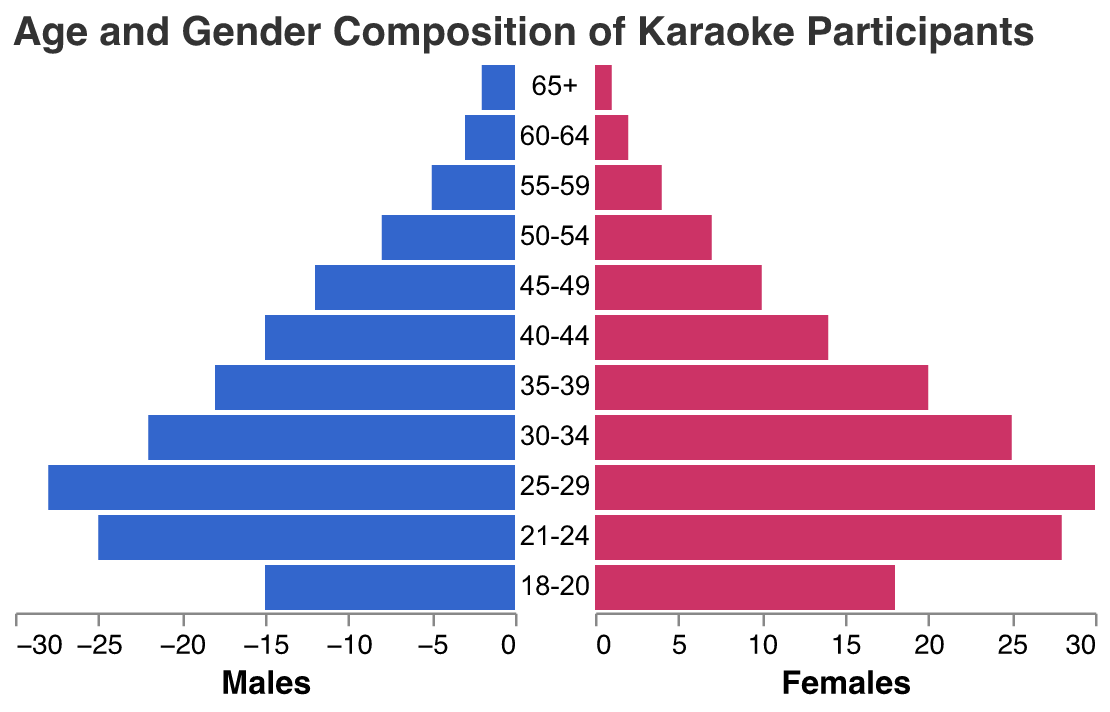What is the title of the figure? The title of the figure can be found at the top of the visual, clearly indicating what the data represents.
Answer: Age and Gender Composition of Karaoke Participants What age group has the highest number of male participants? Locate the age group with the longest bar in the left (blue) section of the pyramid.
Answer: 25-29 In the age group 30-34, how many females are there? Find the bar corresponding to the 30-34 age group in the right (red) section of the pyramid and read its value.
Answer: 25 Which gender has more participants in the 21-24 age group? Compare lengths of the bars for both genders in the 21-24 age group on both sides of the pyramid.
Answer: Females What is the total number of karaoke participants in the age group 45-49? Sum the male and female participants for the 45-49 age group.
Answer: 22 Which age group has a greater difference in the number of male and female participants? For each age group, calculate the absolute difference between males and females, then identify the largest difference.
Answer: 18-20 What is the smallest category of participants for both genders? Locate the age group with the shortest bars on both sides of the pyramid.
Answer: 65+ How many total female participants are there in the data? Sum the number of females across all age groups.
Answer: 159 Which age group has the closest number of participants between genders? Identify the age group where the difference between male and female participants is minimal.
Answer: 55-59 What percentage of participants in the 25-29 age group are male? Calculate the percentage by dividing the number of males by the total number in the 25-29 age group and then multiplying by 100. (28 / (28+30)) * 100
Answer: 48.28% 